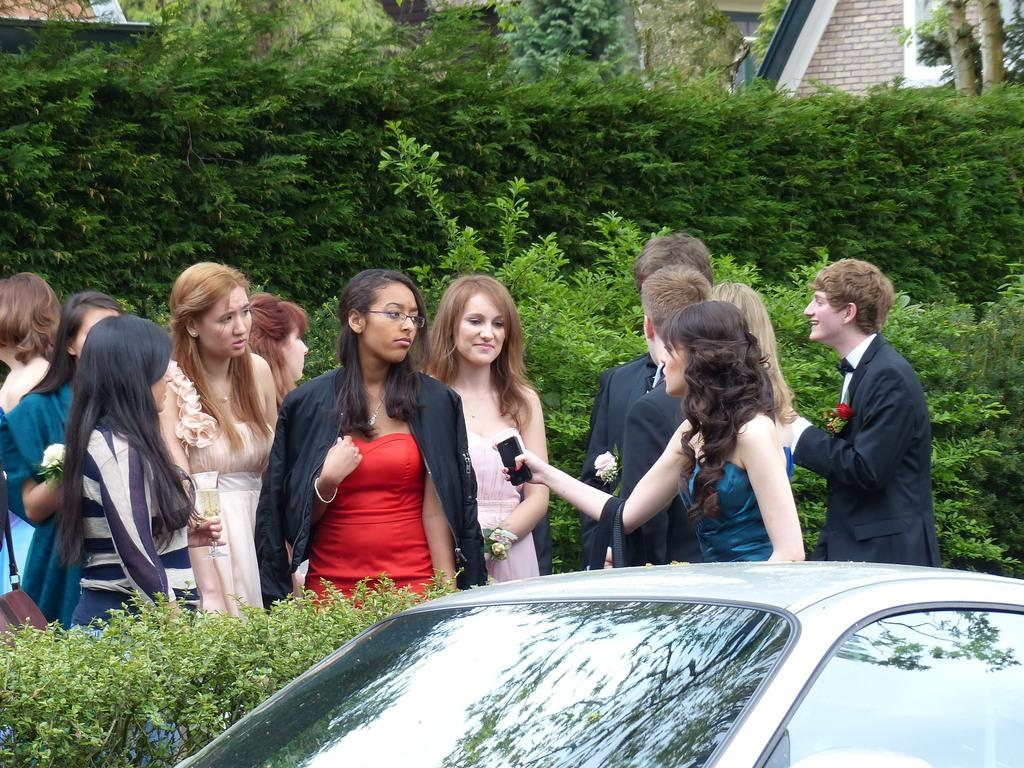What are the people in the image doing? The people in the image are standing and holding a cell phone and a glass. What object is visible in the hands of the people? The people are holding a cell phone and a glass. What is in front of the people in the image? There is a car in front of the people. What can be seen at the back of the image? There are trees and a house at the back of the image. What type of bell can be heard ringing in the image? There is no bell present or ringing in the image. Can you see any deer in the image? There are no deer visible in the image. 